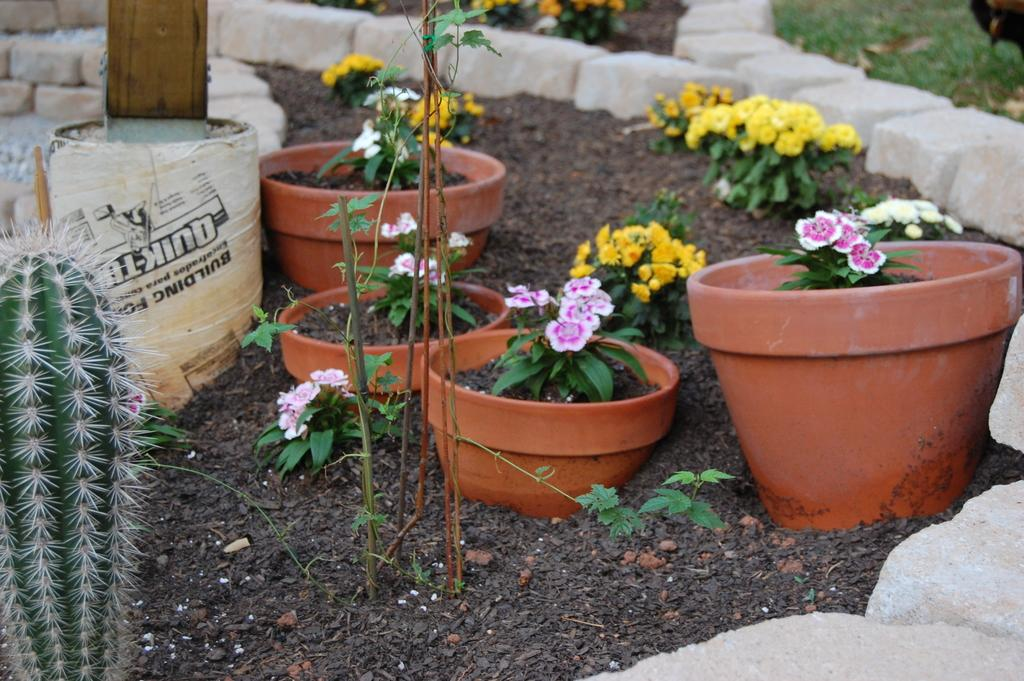What type of living organisms can be seen in the image? Plants, flowers, and a cactus are visible in the image. What are the plants contained in? There are flower pots in the image. Where is the cactus located in the image? The cactus is on the left side of the image. What is present in the background of the image? There is a container in the background of the image. What material is used at the bottom of the image? Bricks are present at the bottom of the image. What type of fact can be learned about planes in the image? There are no planes present in the image, so no facts about planes can be learned from it. 